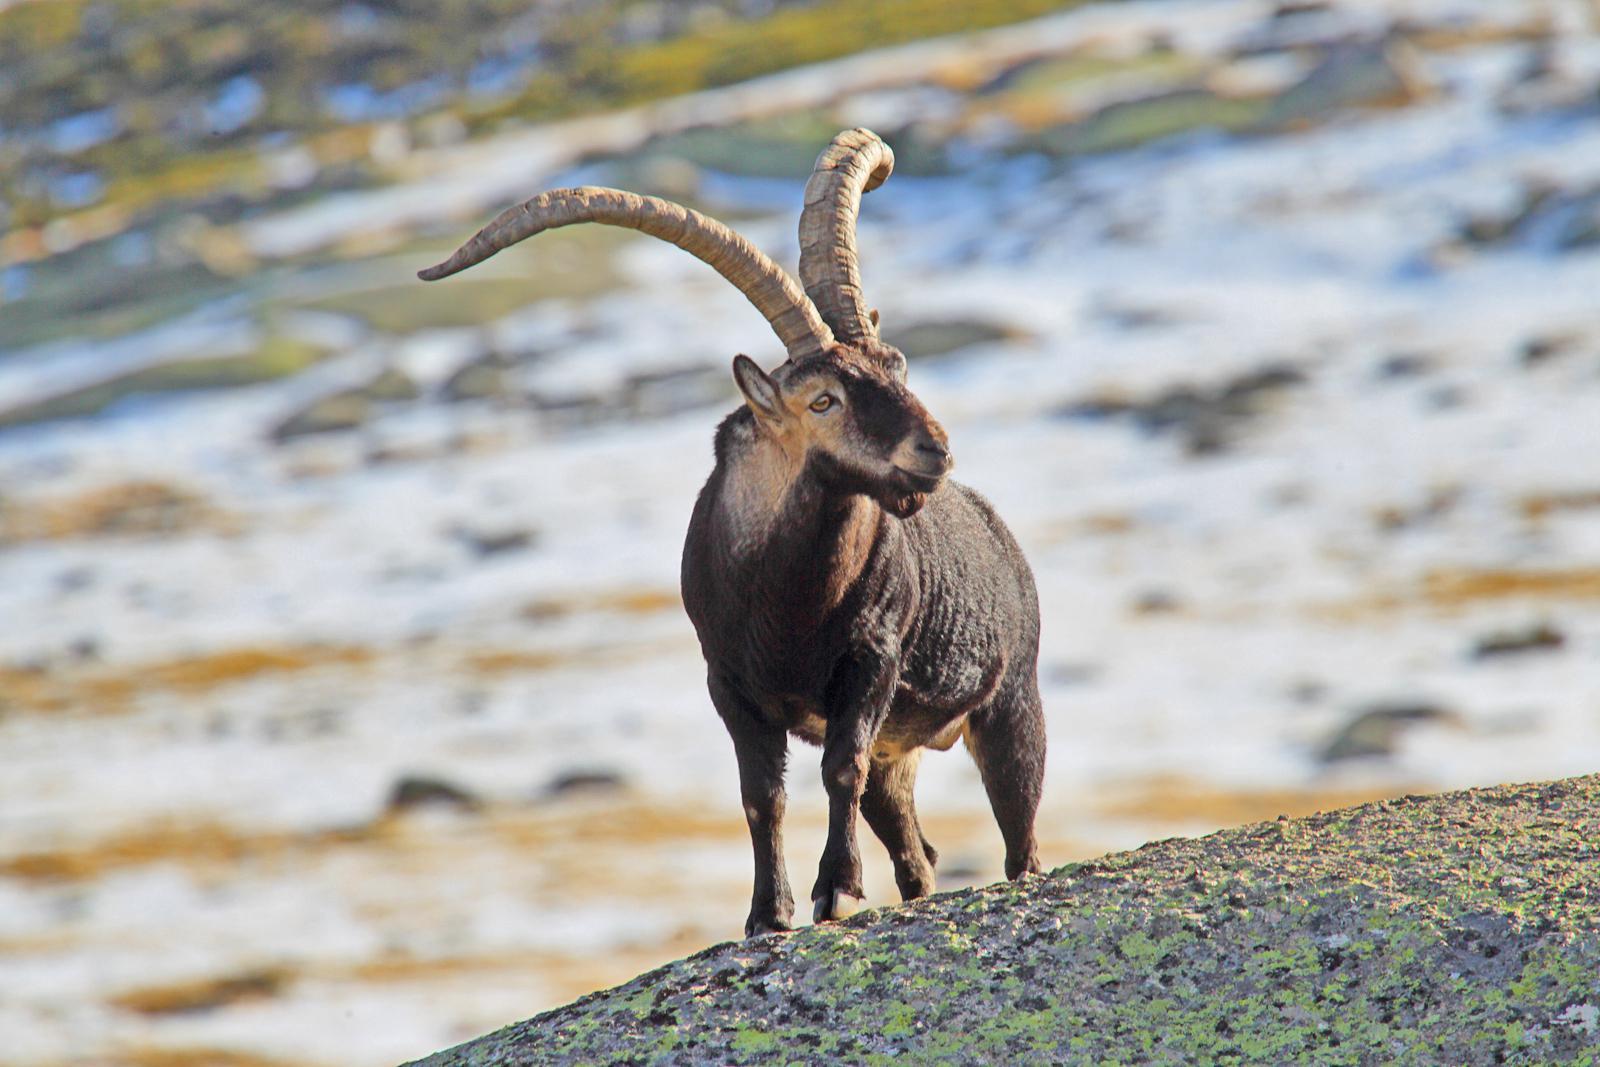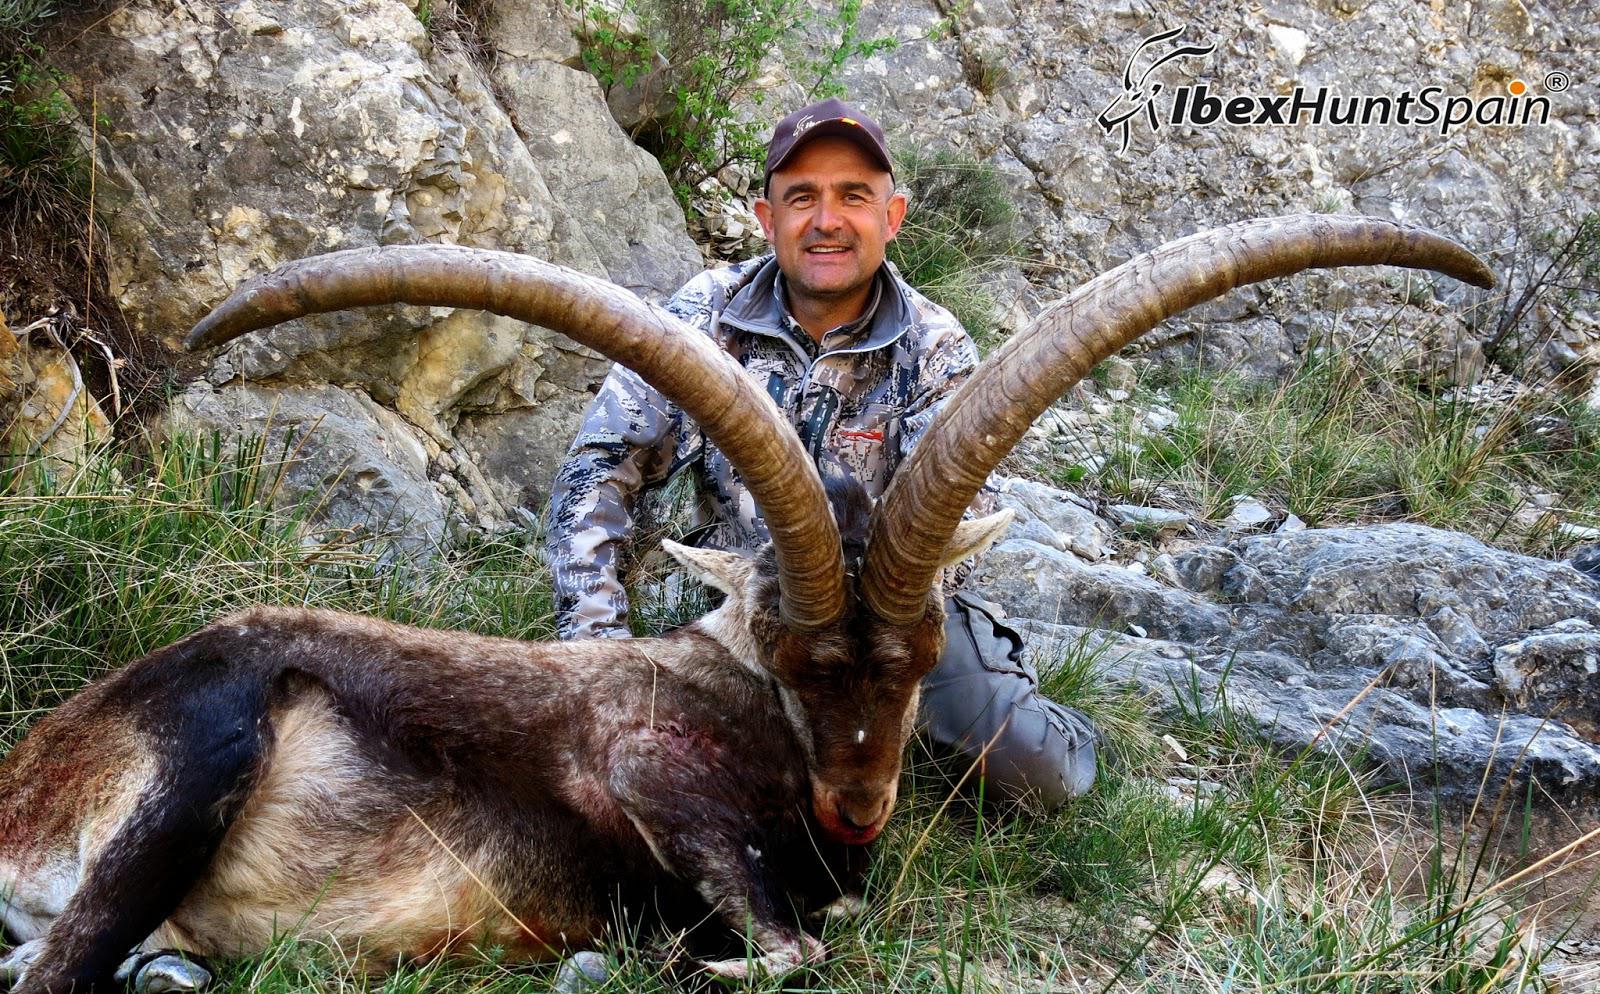The first image is the image on the left, the second image is the image on the right. Assess this claim about the two images: "The left and right image contains a total of  two goats with at least two hunters.". Correct or not? Answer yes or no. No. The first image is the image on the left, the second image is the image on the right. Analyze the images presented: Is the assertion "The left picture does not have a human in it." valid? Answer yes or no. Yes. 